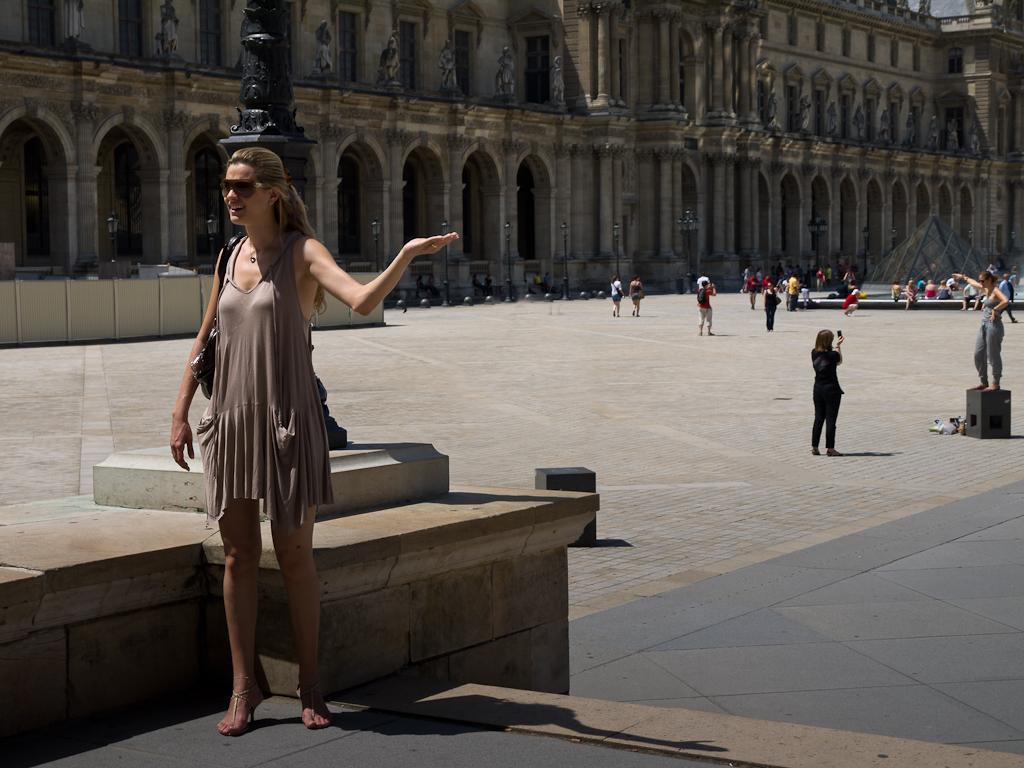Please provide a concise description of this image. In this image in the foreground a lady is standing wearing sunglasses. Behind her there is a pole. In the background there is a building. Many people are there in front of the building. 